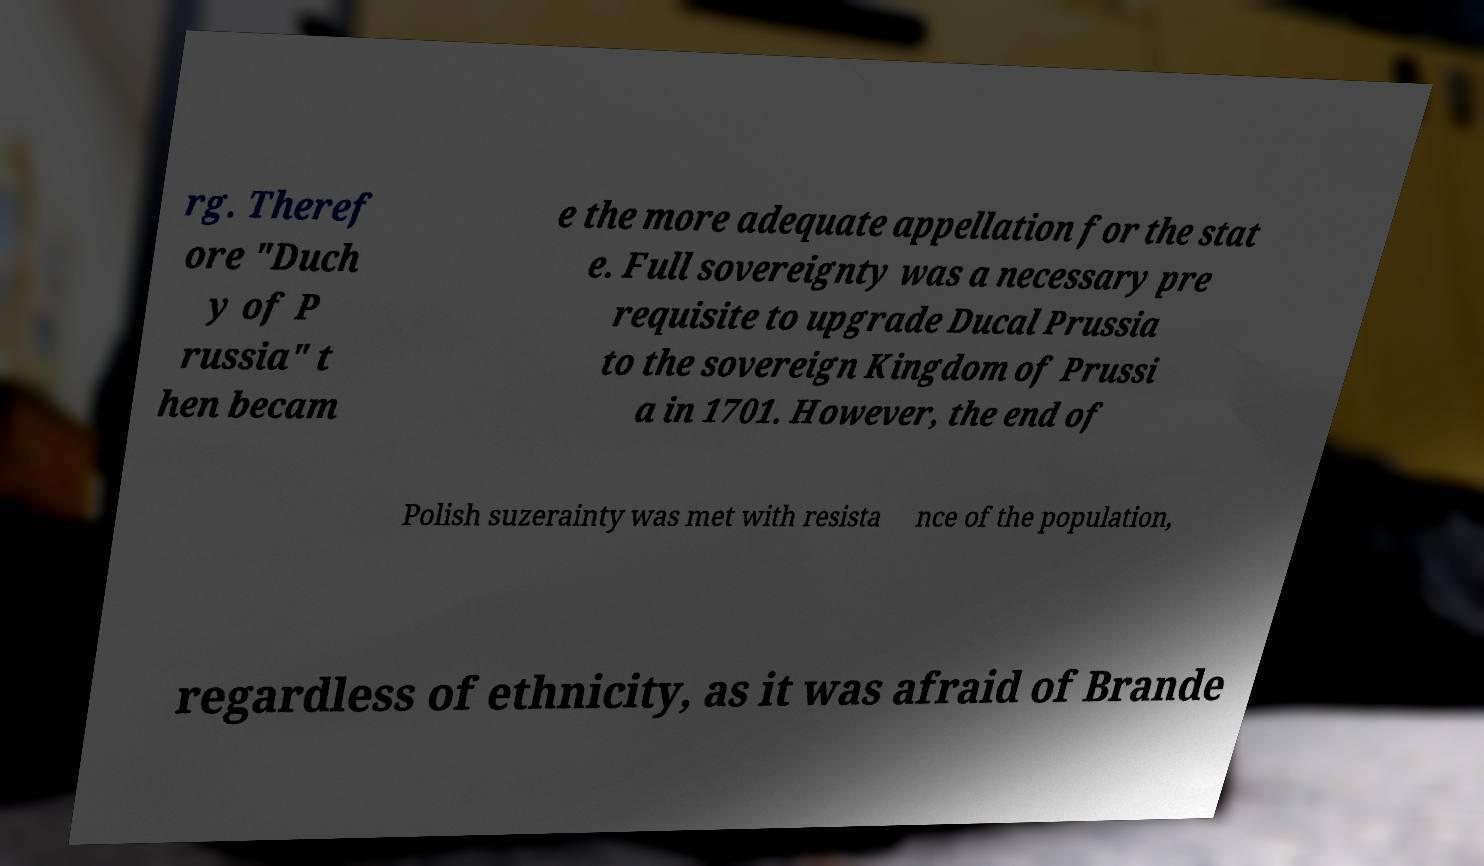I need the written content from this picture converted into text. Can you do that? rg. Theref ore "Duch y of P russia" t hen becam e the more adequate appellation for the stat e. Full sovereignty was a necessary pre requisite to upgrade Ducal Prussia to the sovereign Kingdom of Prussi a in 1701. However, the end of Polish suzerainty was met with resista nce of the population, regardless of ethnicity, as it was afraid of Brande 